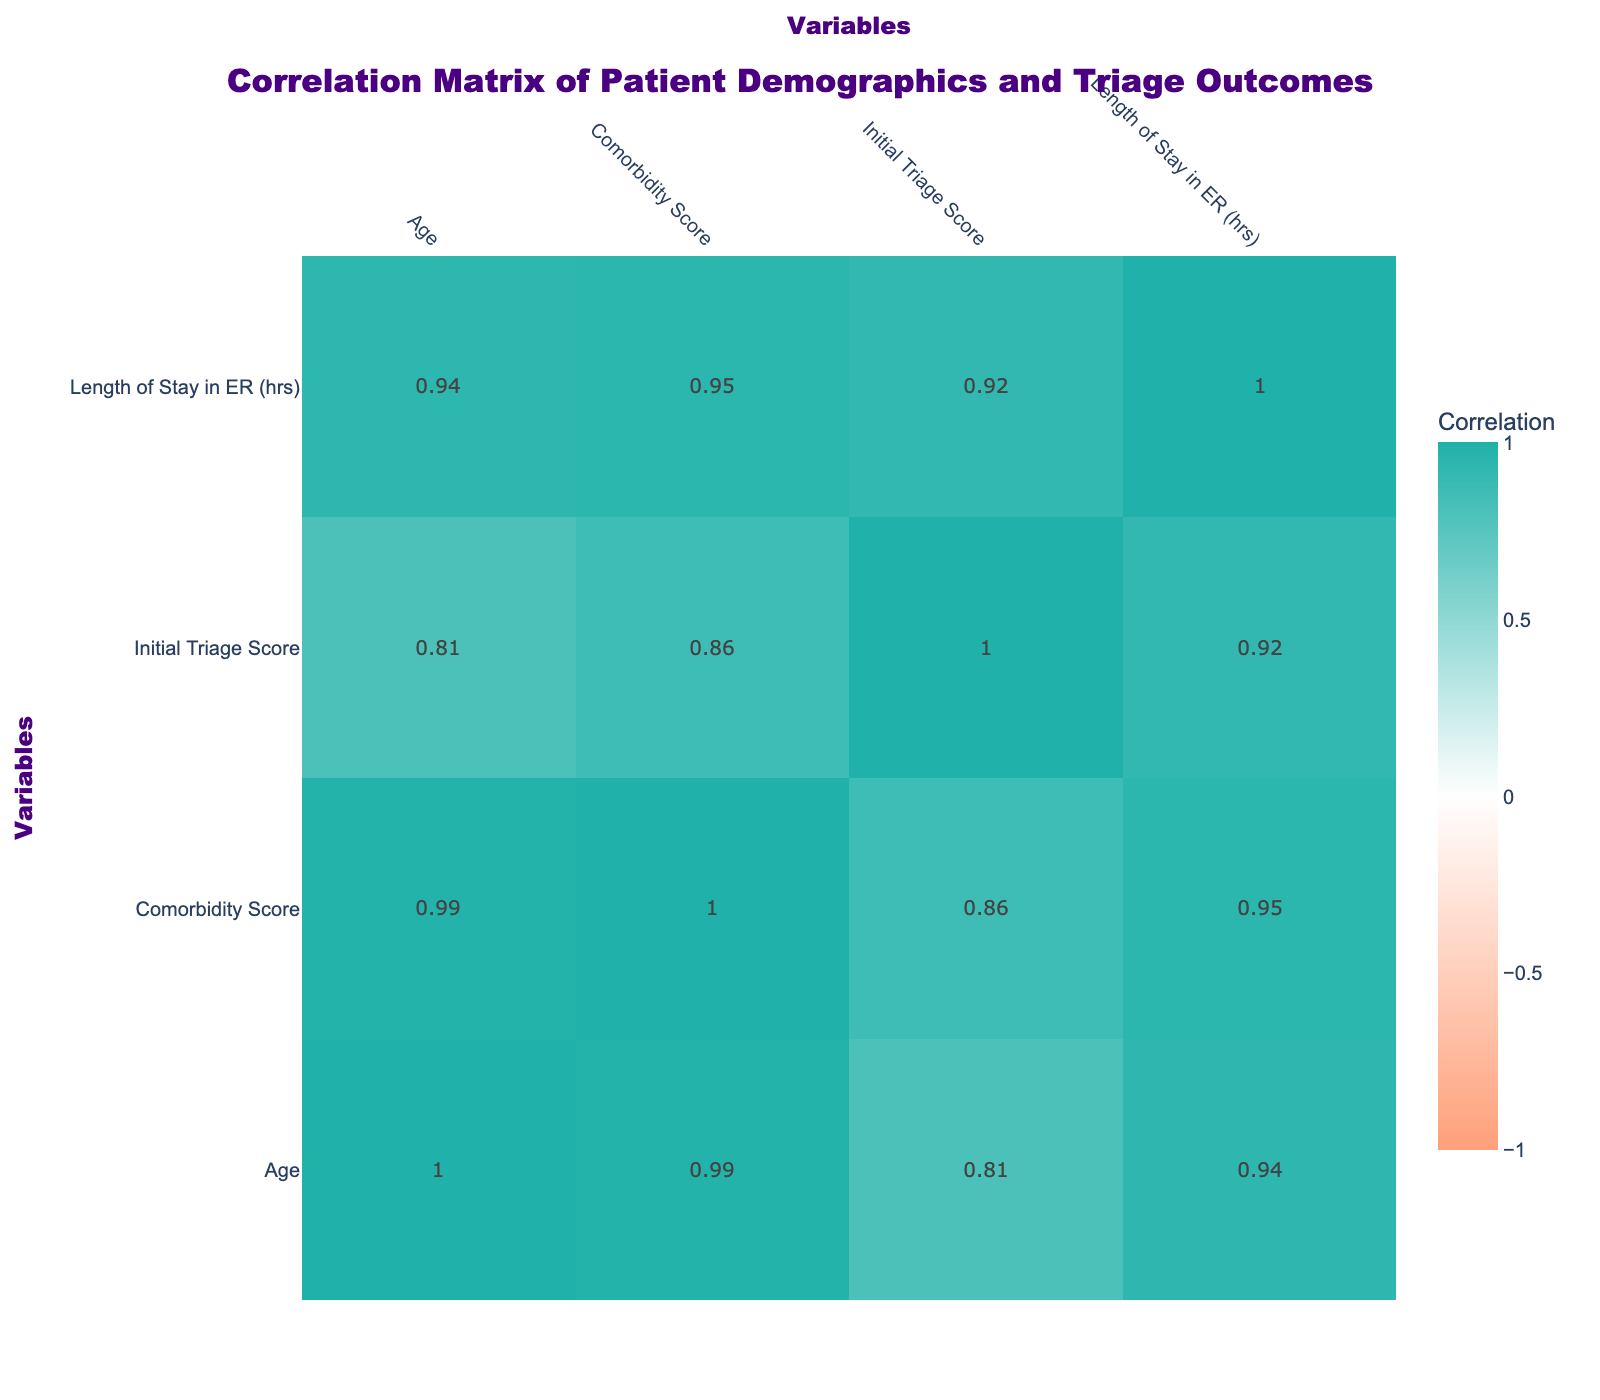What is the correlation between age and initial triage score? The correlation value between age and initial triage score is a positive number found in the correlation table, indicating that as age increases, the initial triage score also tends to increase.
Answer: Positive correlation Is there a significant correlation between gender and length of stay in the ER? Gender and length of stay in the ER do not show a substantial correlation; the correlation value is close to zero, suggesting that gender does not influence how long patients stay in the emergency room.
Answer: No What is the average comorbidity score for those who were admitted? To find the average comorbidity score for admitted patients, we first identify the admitted patients: ages 45, 60, 55, 42, and 67 with comorbidity scores of 2, 4, 3, 2, and 5, respectively. Adding these scores gives 16, and dividing by the number of admitted patients (5) results in an average of 3.2.
Answer: 3.2 Do patients with higher initial triage scores tend to have longer lengths of stay in the ER? The correlation table shows a positive correlation between initial triage score and length of stay. This suggests that as the initial triage score increases, the length of stay in the ER also increases. Hence, we can conclude that there is a tendency for patients with higher initial triage scores to stay longer.
Answer: Yes What is the difference in comorbidity scores between male and female patients? By analyzing the data, we categorize male patients with scores of 0, 4, 3, 2, and female patients with scores of 1, 2, 5. The average for males is (0 + 4 + 3 + 2) / 4 = 2.25, and for females, (1 + 1 + 2 + 5) / 4 = 2.25. The difference in their average scores is 2.25 - 2.25 = 0.
Answer: 0 Is the discharge outcome more favorable for patients with higher initial triage scores? Analyzing the correlation value shows that as the initial triage score increases, the likelihood of being admitted also increases. Hence, a favorable discharge outcome tends to correlate with lower initial triage scores; thus, higher scores are linked to admissions.
Answer: No 